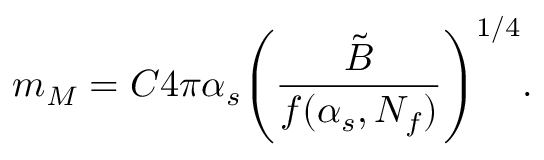Convert formula to latex. <formula><loc_0><loc_0><loc_500><loc_500>m _ { M } = C 4 \pi \alpha _ { s } \left ( { \frac { \tilde { B } } { f ( \alpha _ { s } , N _ { f } ) } } \right ) ^ { 1 / 4 } .</formula> 